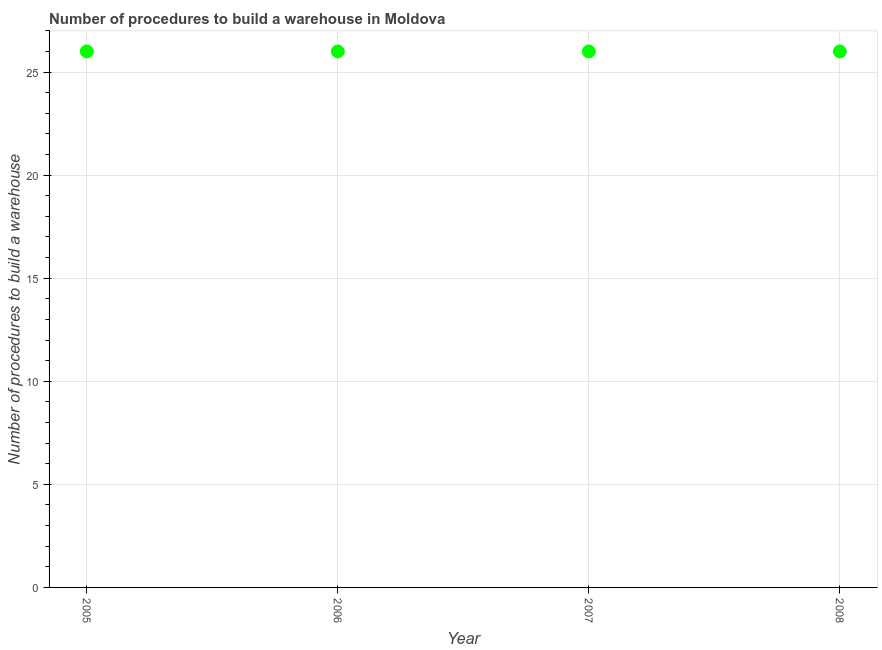What is the number of procedures to build a warehouse in 2008?
Keep it short and to the point. 26. Across all years, what is the maximum number of procedures to build a warehouse?
Give a very brief answer. 26. Across all years, what is the minimum number of procedures to build a warehouse?
Give a very brief answer. 26. In which year was the number of procedures to build a warehouse maximum?
Your answer should be very brief. 2005. What is the sum of the number of procedures to build a warehouse?
Offer a terse response. 104. What is the average number of procedures to build a warehouse per year?
Keep it short and to the point. 26. In how many years, is the number of procedures to build a warehouse greater than 16 ?
Provide a short and direct response. 4. Do a majority of the years between 2005 and 2007 (inclusive) have number of procedures to build a warehouse greater than 3 ?
Ensure brevity in your answer.  Yes. Is the number of procedures to build a warehouse in 2005 less than that in 2007?
Make the answer very short. No. What is the difference between the highest and the second highest number of procedures to build a warehouse?
Your response must be concise. 0. What is the difference between the highest and the lowest number of procedures to build a warehouse?
Your answer should be compact. 0. Does the number of procedures to build a warehouse monotonically increase over the years?
Provide a succinct answer. No. How many dotlines are there?
Your answer should be compact. 1. Does the graph contain grids?
Keep it short and to the point. Yes. What is the title of the graph?
Give a very brief answer. Number of procedures to build a warehouse in Moldova. What is the label or title of the Y-axis?
Keep it short and to the point. Number of procedures to build a warehouse. What is the Number of procedures to build a warehouse in 2007?
Provide a succinct answer. 26. What is the difference between the Number of procedures to build a warehouse in 2005 and 2006?
Give a very brief answer. 0. What is the ratio of the Number of procedures to build a warehouse in 2005 to that in 2007?
Your answer should be very brief. 1. What is the ratio of the Number of procedures to build a warehouse in 2006 to that in 2007?
Make the answer very short. 1. What is the ratio of the Number of procedures to build a warehouse in 2006 to that in 2008?
Your answer should be very brief. 1. What is the ratio of the Number of procedures to build a warehouse in 2007 to that in 2008?
Provide a succinct answer. 1. 